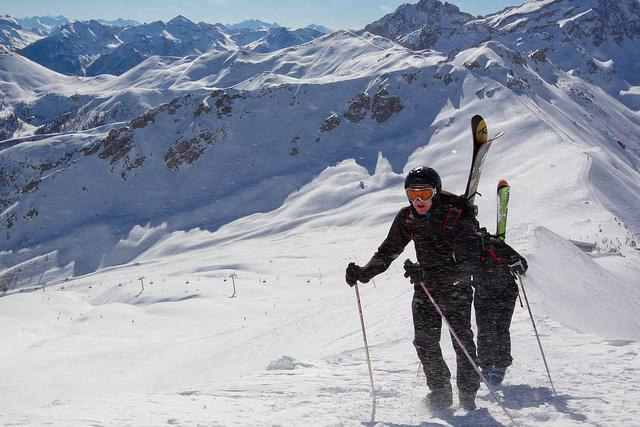What is the primary color of the skis carried on the back of the man following the man?

Choices:
A) black
B) green
C) red
D) yellow green 